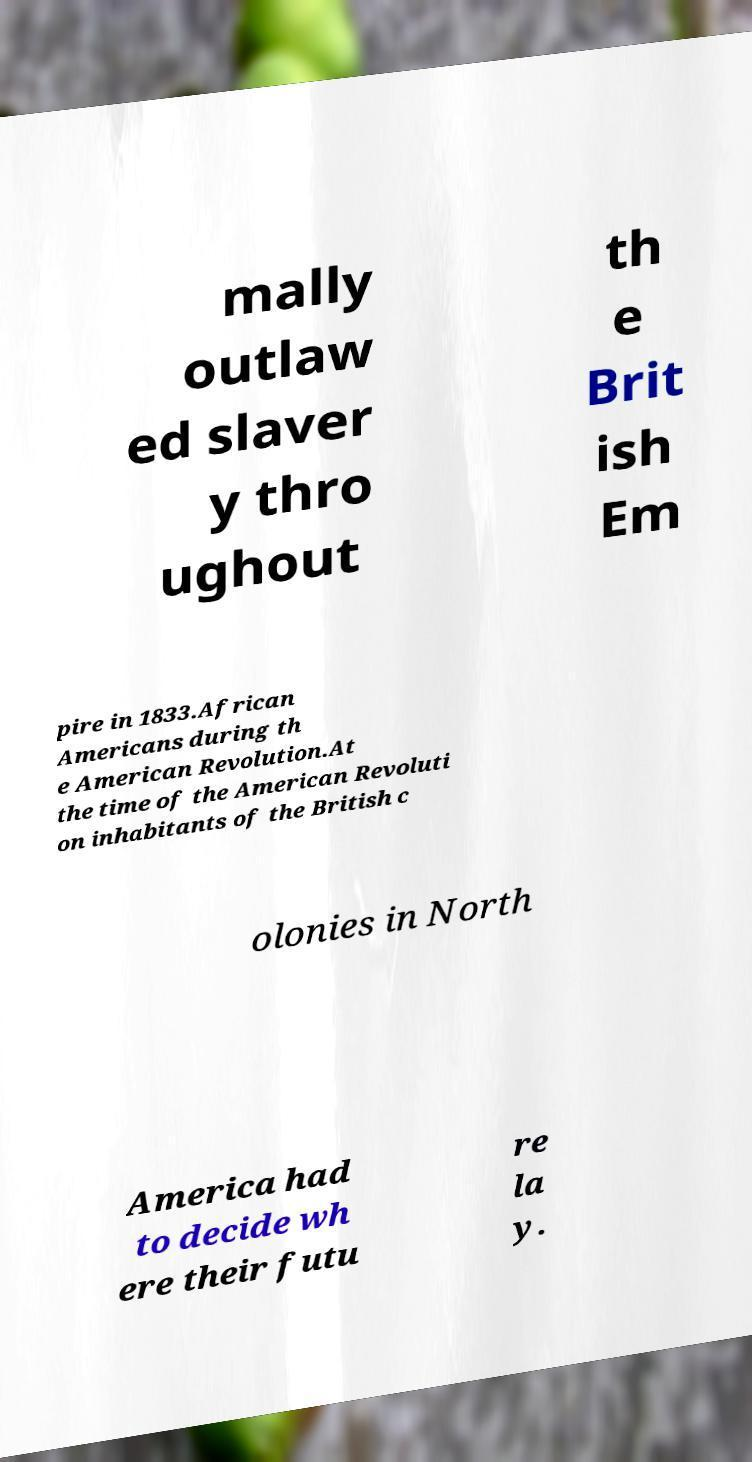Can you read and provide the text displayed in the image?This photo seems to have some interesting text. Can you extract and type it out for me? mally outlaw ed slaver y thro ughout th e Brit ish Em pire in 1833.African Americans during th e American Revolution.At the time of the American Revoluti on inhabitants of the British c olonies in North America had to decide wh ere their futu re la y. 